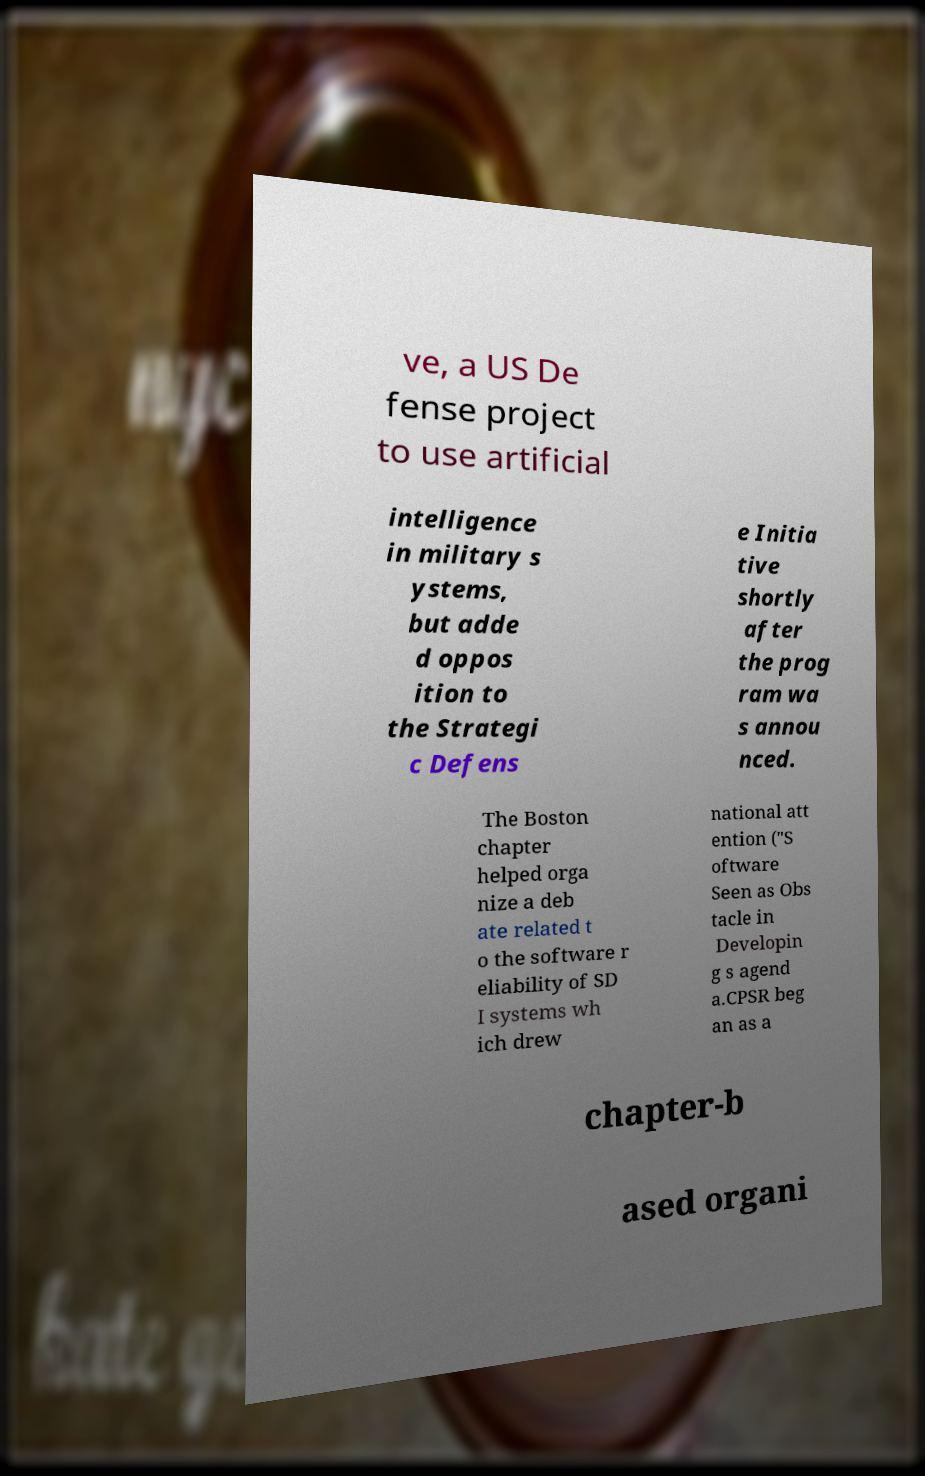Could you assist in decoding the text presented in this image and type it out clearly? ve, a US De fense project to use artificial intelligence in military s ystems, but adde d oppos ition to the Strategi c Defens e Initia tive shortly after the prog ram wa s annou nced. The Boston chapter helped orga nize a deb ate related t o the software r eliability of SD I systems wh ich drew national att ention ("S oftware Seen as Obs tacle in Developin g s agend a.CPSR beg an as a chapter-b ased organi 